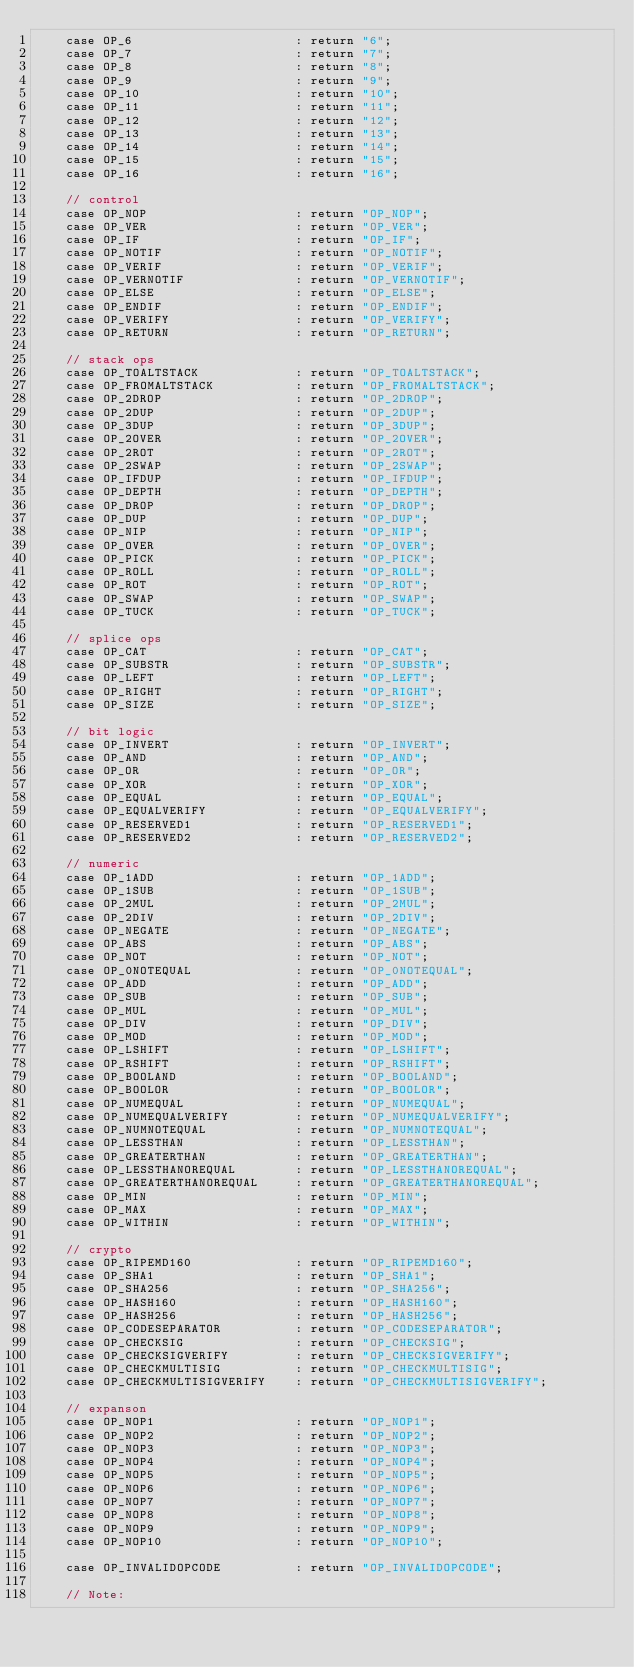Convert code to text. <code><loc_0><loc_0><loc_500><loc_500><_C++_>    case OP_6                      : return "6";
    case OP_7                      : return "7";
    case OP_8                      : return "8";
    case OP_9                      : return "9";
    case OP_10                     : return "10";
    case OP_11                     : return "11";
    case OP_12                     : return "12";
    case OP_13                     : return "13";
    case OP_14                     : return "14";
    case OP_15                     : return "15";
    case OP_16                     : return "16";

    // control
    case OP_NOP                    : return "OP_NOP";
    case OP_VER                    : return "OP_VER";
    case OP_IF                     : return "OP_IF";
    case OP_NOTIF                  : return "OP_NOTIF";
    case OP_VERIF                  : return "OP_VERIF";
    case OP_VERNOTIF               : return "OP_VERNOTIF";
    case OP_ELSE                   : return "OP_ELSE";
    case OP_ENDIF                  : return "OP_ENDIF";
    case OP_VERIFY                 : return "OP_VERIFY";
    case OP_RETURN                 : return "OP_RETURN";

    // stack ops
    case OP_TOALTSTACK             : return "OP_TOALTSTACK";
    case OP_FROMALTSTACK           : return "OP_FROMALTSTACK";
    case OP_2DROP                  : return "OP_2DROP";
    case OP_2DUP                   : return "OP_2DUP";
    case OP_3DUP                   : return "OP_3DUP";
    case OP_2OVER                  : return "OP_2OVER";
    case OP_2ROT                   : return "OP_2ROT";
    case OP_2SWAP                  : return "OP_2SWAP";
    case OP_IFDUP                  : return "OP_IFDUP";
    case OP_DEPTH                  : return "OP_DEPTH";
    case OP_DROP                   : return "OP_DROP";
    case OP_DUP                    : return "OP_DUP";
    case OP_NIP                    : return "OP_NIP";
    case OP_OVER                   : return "OP_OVER";
    case OP_PICK                   : return "OP_PICK";
    case OP_ROLL                   : return "OP_ROLL";
    case OP_ROT                    : return "OP_ROT";
    case OP_SWAP                   : return "OP_SWAP";
    case OP_TUCK                   : return "OP_TUCK";

    // splice ops
    case OP_CAT                    : return "OP_CAT";
    case OP_SUBSTR                 : return "OP_SUBSTR";
    case OP_LEFT                   : return "OP_LEFT";
    case OP_RIGHT                  : return "OP_RIGHT";
    case OP_SIZE                   : return "OP_SIZE";

    // bit logic
    case OP_INVERT                 : return "OP_INVERT";
    case OP_AND                    : return "OP_AND";
    case OP_OR                     : return "OP_OR";
    case OP_XOR                    : return "OP_XOR";
    case OP_EQUAL                  : return "OP_EQUAL";
    case OP_EQUALVERIFY            : return "OP_EQUALVERIFY";
    case OP_RESERVED1              : return "OP_RESERVED1";
    case OP_RESERVED2              : return "OP_RESERVED2";

    // numeric
    case OP_1ADD                   : return "OP_1ADD";
    case OP_1SUB                   : return "OP_1SUB";
    case OP_2MUL                   : return "OP_2MUL";
    case OP_2DIV                   : return "OP_2DIV";
    case OP_NEGATE                 : return "OP_NEGATE";
    case OP_ABS                    : return "OP_ABS";
    case OP_NOT                    : return "OP_NOT";
    case OP_0NOTEQUAL              : return "OP_0NOTEQUAL";
    case OP_ADD                    : return "OP_ADD";
    case OP_SUB                    : return "OP_SUB";
    case OP_MUL                    : return "OP_MUL";
    case OP_DIV                    : return "OP_DIV";
    case OP_MOD                    : return "OP_MOD";
    case OP_LSHIFT                 : return "OP_LSHIFT";
    case OP_RSHIFT                 : return "OP_RSHIFT";
    case OP_BOOLAND                : return "OP_BOOLAND";
    case OP_BOOLOR                 : return "OP_BOOLOR";
    case OP_NUMEQUAL               : return "OP_NUMEQUAL";
    case OP_NUMEQUALVERIFY         : return "OP_NUMEQUALVERIFY";
    case OP_NUMNOTEQUAL            : return "OP_NUMNOTEQUAL";
    case OP_LESSTHAN               : return "OP_LESSTHAN";
    case OP_GREATERTHAN            : return "OP_GREATERTHAN";
    case OP_LESSTHANOREQUAL        : return "OP_LESSTHANOREQUAL";
    case OP_GREATERTHANOREQUAL     : return "OP_GREATERTHANOREQUAL";
    case OP_MIN                    : return "OP_MIN";
    case OP_MAX                    : return "OP_MAX";
    case OP_WITHIN                 : return "OP_WITHIN";

    // crypto
    case OP_RIPEMD160              : return "OP_RIPEMD160";
    case OP_SHA1                   : return "OP_SHA1";
    case OP_SHA256                 : return "OP_SHA256";
    case OP_HASH160                : return "OP_HASH160";
    case OP_HASH256                : return "OP_HASH256";
    case OP_CODESEPARATOR          : return "OP_CODESEPARATOR";
    case OP_CHECKSIG               : return "OP_CHECKSIG";
    case OP_CHECKSIGVERIFY         : return "OP_CHECKSIGVERIFY";
    case OP_CHECKMULTISIG          : return "OP_CHECKMULTISIG";
    case OP_CHECKMULTISIGVERIFY    : return "OP_CHECKMULTISIGVERIFY";

    // expanson
    case OP_NOP1                   : return "OP_NOP1";
    case OP_NOP2                   : return "OP_NOP2";
    case OP_NOP3                   : return "OP_NOP3";
    case OP_NOP4                   : return "OP_NOP4";
    case OP_NOP5                   : return "OP_NOP5";
    case OP_NOP6                   : return "OP_NOP6";
    case OP_NOP7                   : return "OP_NOP7";
    case OP_NOP8                   : return "OP_NOP8";
    case OP_NOP9                   : return "OP_NOP9";
    case OP_NOP10                  : return "OP_NOP10";

    case OP_INVALIDOPCODE          : return "OP_INVALIDOPCODE";

    // Note:</code> 